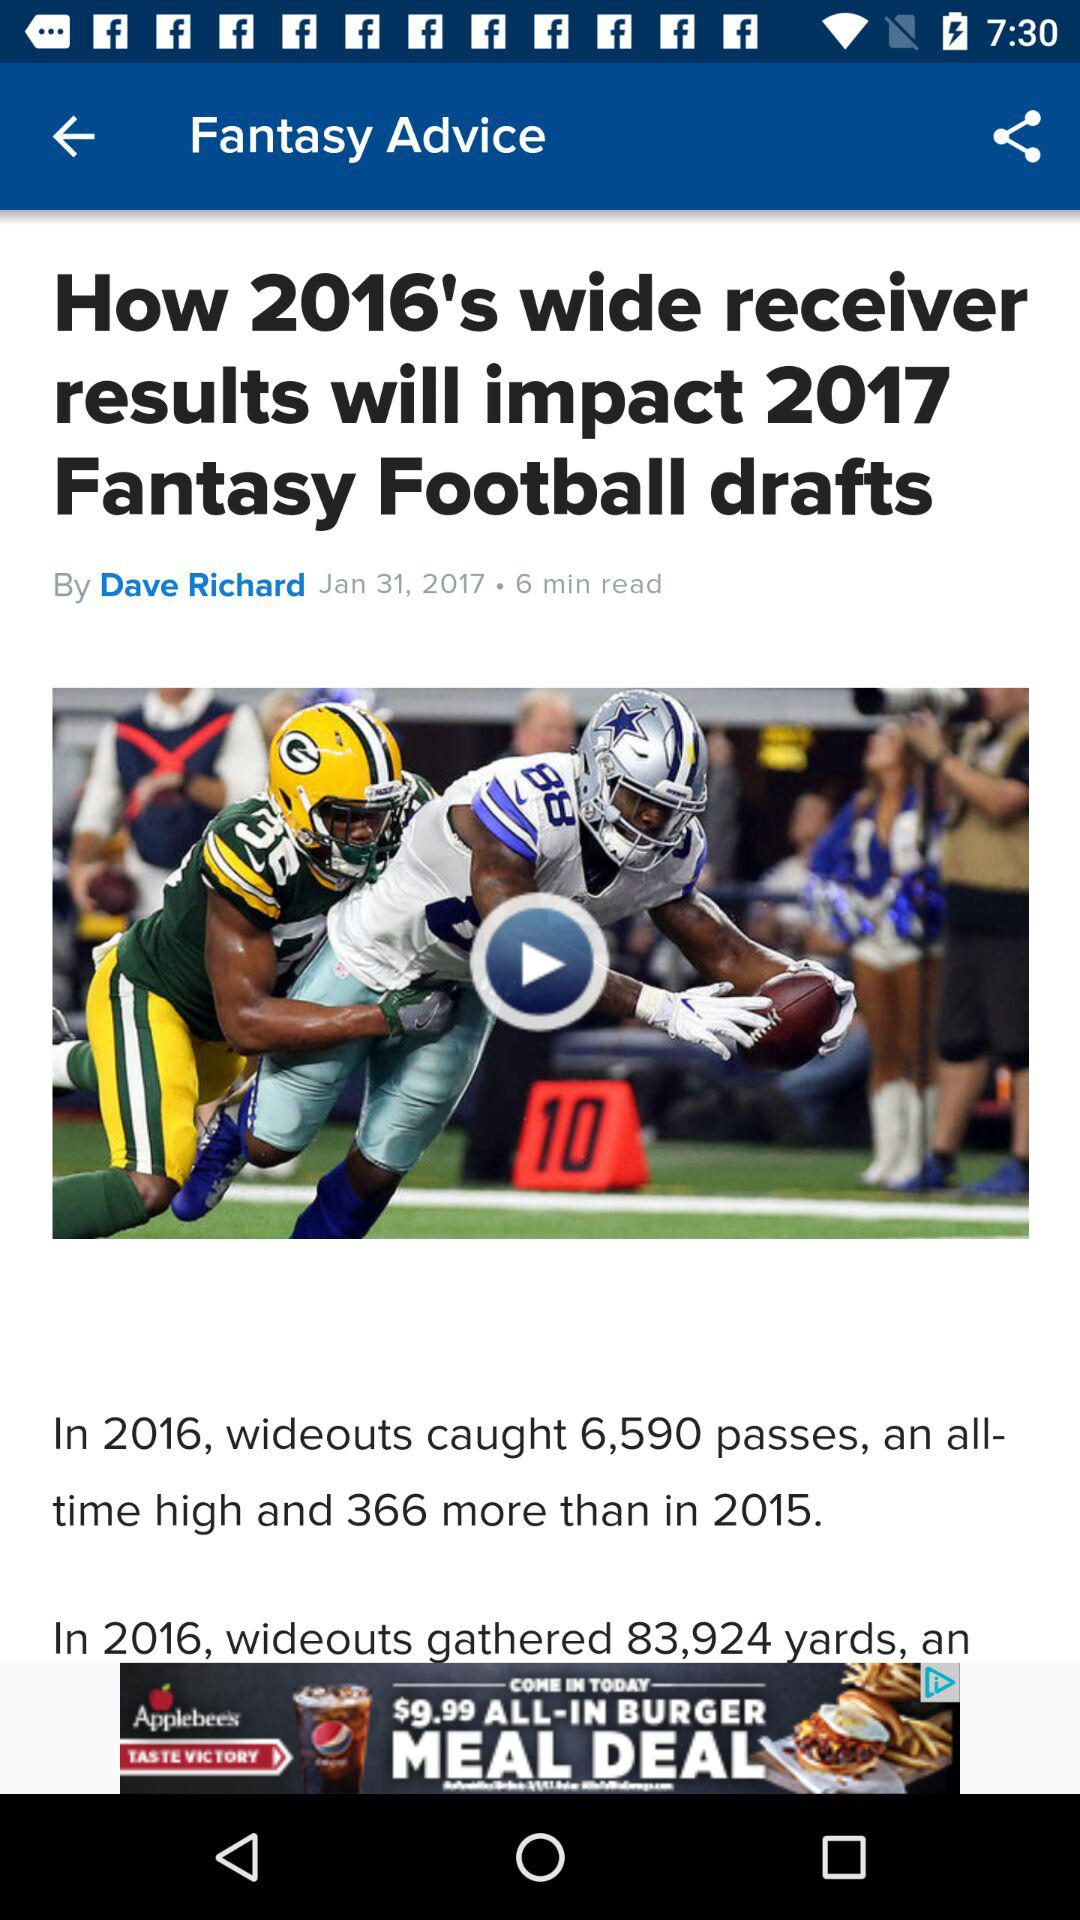How many more passes did wideouts catch in 2016 than in 2015?
Answer the question using a single word or phrase. 366 